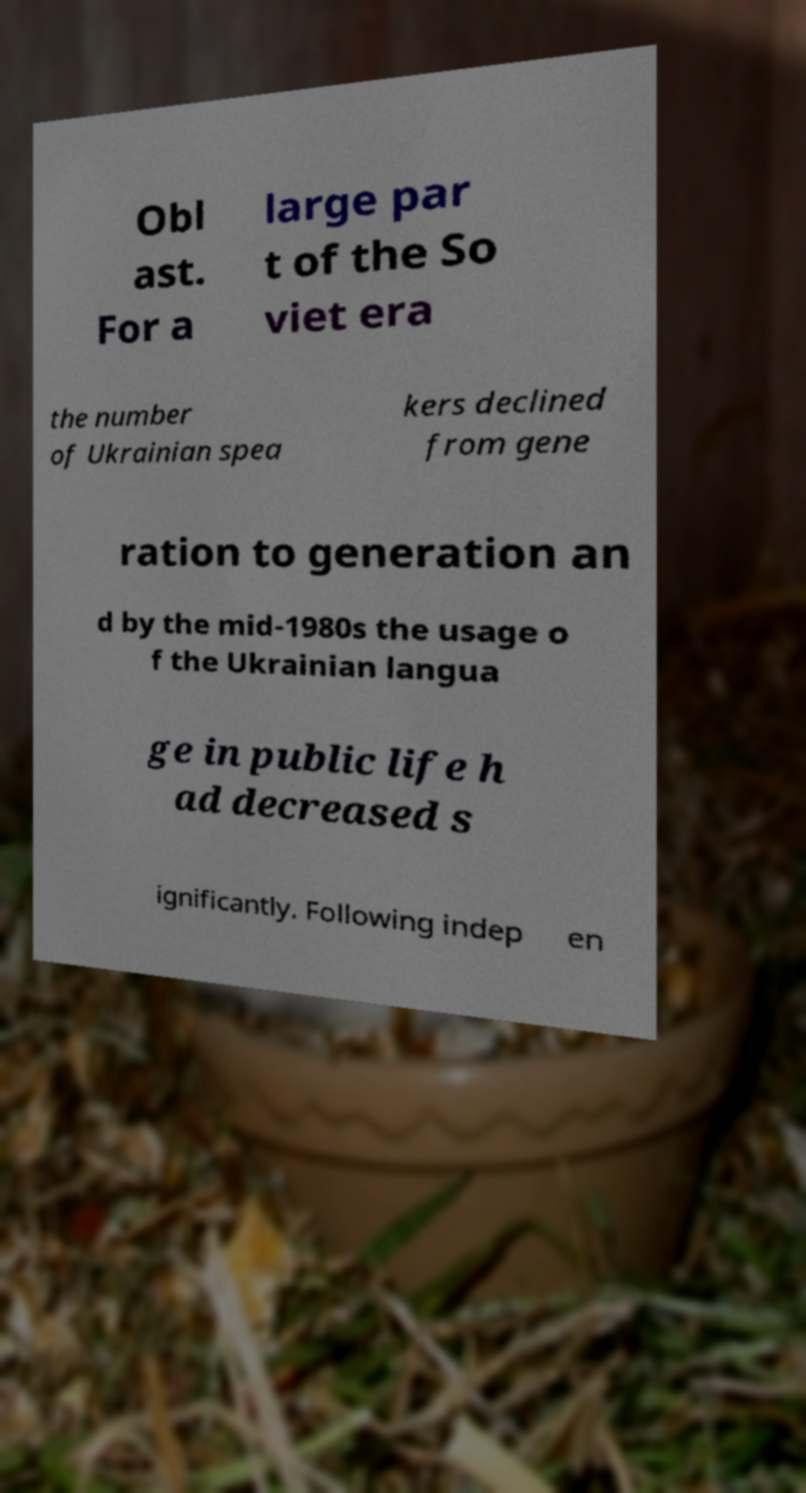Please read and relay the text visible in this image. What does it say? Obl ast. For a large par t of the So viet era the number of Ukrainian spea kers declined from gene ration to generation an d by the mid-1980s the usage o f the Ukrainian langua ge in public life h ad decreased s ignificantly. Following indep en 